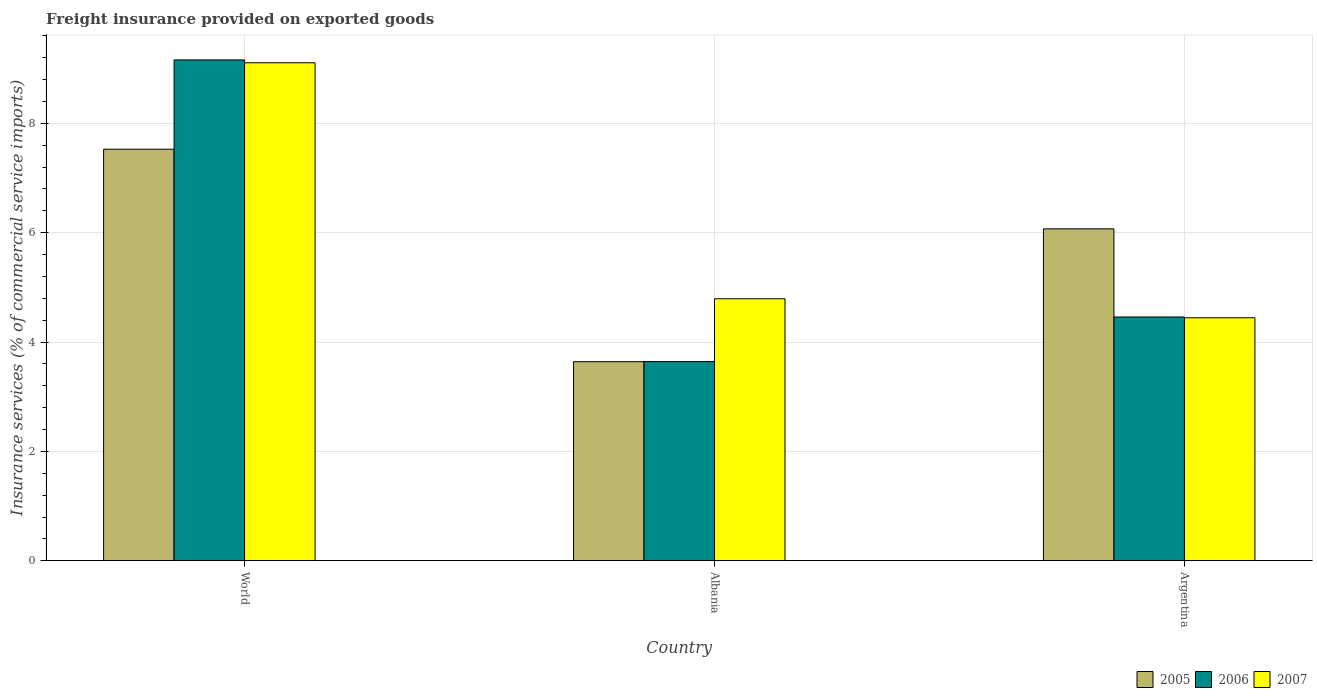How many groups of bars are there?
Offer a terse response. 3. Are the number of bars per tick equal to the number of legend labels?
Provide a succinct answer. Yes. How many bars are there on the 2nd tick from the right?
Give a very brief answer. 3. What is the label of the 2nd group of bars from the left?
Your response must be concise. Albania. What is the freight insurance provided on exported goods in 2006 in Argentina?
Ensure brevity in your answer.  4.46. Across all countries, what is the maximum freight insurance provided on exported goods in 2007?
Give a very brief answer. 9.11. Across all countries, what is the minimum freight insurance provided on exported goods in 2007?
Offer a terse response. 4.44. In which country was the freight insurance provided on exported goods in 2006 maximum?
Ensure brevity in your answer.  World. What is the total freight insurance provided on exported goods in 2006 in the graph?
Your response must be concise. 17.26. What is the difference between the freight insurance provided on exported goods in 2005 in Albania and that in Argentina?
Ensure brevity in your answer.  -2.43. What is the difference between the freight insurance provided on exported goods in 2005 in World and the freight insurance provided on exported goods in 2006 in Albania?
Offer a terse response. 3.88. What is the average freight insurance provided on exported goods in 2005 per country?
Give a very brief answer. 5.75. What is the difference between the freight insurance provided on exported goods of/in 2006 and freight insurance provided on exported goods of/in 2007 in Albania?
Your response must be concise. -1.15. In how many countries, is the freight insurance provided on exported goods in 2007 greater than 2.8 %?
Keep it short and to the point. 3. What is the ratio of the freight insurance provided on exported goods in 2006 in Albania to that in World?
Make the answer very short. 0.4. What is the difference between the highest and the second highest freight insurance provided on exported goods in 2006?
Ensure brevity in your answer.  5.52. What is the difference between the highest and the lowest freight insurance provided on exported goods in 2007?
Provide a succinct answer. 4.66. In how many countries, is the freight insurance provided on exported goods in 2005 greater than the average freight insurance provided on exported goods in 2005 taken over all countries?
Make the answer very short. 2. What does the 3rd bar from the left in Albania represents?
Keep it short and to the point. 2007. What does the 1st bar from the right in Argentina represents?
Offer a very short reply. 2007. Is it the case that in every country, the sum of the freight insurance provided on exported goods in 2006 and freight insurance provided on exported goods in 2005 is greater than the freight insurance provided on exported goods in 2007?
Keep it short and to the point. Yes. How many bars are there?
Keep it short and to the point. 9. Are all the bars in the graph horizontal?
Provide a succinct answer. No. What is the difference between two consecutive major ticks on the Y-axis?
Offer a very short reply. 2. Are the values on the major ticks of Y-axis written in scientific E-notation?
Provide a short and direct response. No. Where does the legend appear in the graph?
Keep it short and to the point. Bottom right. How many legend labels are there?
Your answer should be compact. 3. How are the legend labels stacked?
Your response must be concise. Horizontal. What is the title of the graph?
Keep it short and to the point. Freight insurance provided on exported goods. What is the label or title of the Y-axis?
Give a very brief answer. Insurance services (% of commercial service imports). What is the Insurance services (% of commercial service imports) in 2005 in World?
Offer a terse response. 7.53. What is the Insurance services (% of commercial service imports) of 2006 in World?
Your response must be concise. 9.16. What is the Insurance services (% of commercial service imports) of 2007 in World?
Provide a short and direct response. 9.11. What is the Insurance services (% of commercial service imports) of 2005 in Albania?
Give a very brief answer. 3.64. What is the Insurance services (% of commercial service imports) in 2006 in Albania?
Offer a very short reply. 3.64. What is the Insurance services (% of commercial service imports) in 2007 in Albania?
Provide a short and direct response. 4.79. What is the Insurance services (% of commercial service imports) in 2005 in Argentina?
Provide a short and direct response. 6.07. What is the Insurance services (% of commercial service imports) in 2006 in Argentina?
Offer a very short reply. 4.46. What is the Insurance services (% of commercial service imports) in 2007 in Argentina?
Offer a terse response. 4.44. Across all countries, what is the maximum Insurance services (% of commercial service imports) in 2005?
Provide a short and direct response. 7.53. Across all countries, what is the maximum Insurance services (% of commercial service imports) of 2006?
Offer a terse response. 9.16. Across all countries, what is the maximum Insurance services (% of commercial service imports) in 2007?
Offer a terse response. 9.11. Across all countries, what is the minimum Insurance services (% of commercial service imports) of 2005?
Keep it short and to the point. 3.64. Across all countries, what is the minimum Insurance services (% of commercial service imports) of 2006?
Ensure brevity in your answer.  3.64. Across all countries, what is the minimum Insurance services (% of commercial service imports) in 2007?
Give a very brief answer. 4.44. What is the total Insurance services (% of commercial service imports) in 2005 in the graph?
Provide a succinct answer. 17.23. What is the total Insurance services (% of commercial service imports) of 2006 in the graph?
Your answer should be very brief. 17.26. What is the total Insurance services (% of commercial service imports) of 2007 in the graph?
Provide a short and direct response. 18.34. What is the difference between the Insurance services (% of commercial service imports) of 2005 in World and that in Albania?
Your response must be concise. 3.89. What is the difference between the Insurance services (% of commercial service imports) in 2006 in World and that in Albania?
Your response must be concise. 5.52. What is the difference between the Insurance services (% of commercial service imports) of 2007 in World and that in Albania?
Your answer should be very brief. 4.31. What is the difference between the Insurance services (% of commercial service imports) in 2005 in World and that in Argentina?
Give a very brief answer. 1.46. What is the difference between the Insurance services (% of commercial service imports) of 2006 in World and that in Argentina?
Make the answer very short. 4.7. What is the difference between the Insurance services (% of commercial service imports) in 2007 in World and that in Argentina?
Ensure brevity in your answer.  4.66. What is the difference between the Insurance services (% of commercial service imports) of 2005 in Albania and that in Argentina?
Your response must be concise. -2.43. What is the difference between the Insurance services (% of commercial service imports) in 2006 in Albania and that in Argentina?
Ensure brevity in your answer.  -0.82. What is the difference between the Insurance services (% of commercial service imports) in 2007 in Albania and that in Argentina?
Your answer should be compact. 0.35. What is the difference between the Insurance services (% of commercial service imports) in 2005 in World and the Insurance services (% of commercial service imports) in 2006 in Albania?
Your response must be concise. 3.88. What is the difference between the Insurance services (% of commercial service imports) of 2005 in World and the Insurance services (% of commercial service imports) of 2007 in Albania?
Your response must be concise. 2.73. What is the difference between the Insurance services (% of commercial service imports) of 2006 in World and the Insurance services (% of commercial service imports) of 2007 in Albania?
Ensure brevity in your answer.  4.37. What is the difference between the Insurance services (% of commercial service imports) of 2005 in World and the Insurance services (% of commercial service imports) of 2006 in Argentina?
Offer a terse response. 3.07. What is the difference between the Insurance services (% of commercial service imports) of 2005 in World and the Insurance services (% of commercial service imports) of 2007 in Argentina?
Give a very brief answer. 3.08. What is the difference between the Insurance services (% of commercial service imports) of 2006 in World and the Insurance services (% of commercial service imports) of 2007 in Argentina?
Your response must be concise. 4.71. What is the difference between the Insurance services (% of commercial service imports) in 2005 in Albania and the Insurance services (% of commercial service imports) in 2006 in Argentina?
Your answer should be compact. -0.82. What is the difference between the Insurance services (% of commercial service imports) in 2005 in Albania and the Insurance services (% of commercial service imports) in 2007 in Argentina?
Provide a succinct answer. -0.8. What is the difference between the Insurance services (% of commercial service imports) of 2006 in Albania and the Insurance services (% of commercial service imports) of 2007 in Argentina?
Offer a terse response. -0.8. What is the average Insurance services (% of commercial service imports) of 2005 per country?
Keep it short and to the point. 5.75. What is the average Insurance services (% of commercial service imports) in 2006 per country?
Your answer should be very brief. 5.75. What is the average Insurance services (% of commercial service imports) of 2007 per country?
Your response must be concise. 6.11. What is the difference between the Insurance services (% of commercial service imports) of 2005 and Insurance services (% of commercial service imports) of 2006 in World?
Ensure brevity in your answer.  -1.63. What is the difference between the Insurance services (% of commercial service imports) in 2005 and Insurance services (% of commercial service imports) in 2007 in World?
Offer a terse response. -1.58. What is the difference between the Insurance services (% of commercial service imports) in 2006 and Insurance services (% of commercial service imports) in 2007 in World?
Make the answer very short. 0.05. What is the difference between the Insurance services (% of commercial service imports) of 2005 and Insurance services (% of commercial service imports) of 2006 in Albania?
Provide a succinct answer. -0. What is the difference between the Insurance services (% of commercial service imports) in 2005 and Insurance services (% of commercial service imports) in 2007 in Albania?
Provide a succinct answer. -1.15. What is the difference between the Insurance services (% of commercial service imports) of 2006 and Insurance services (% of commercial service imports) of 2007 in Albania?
Ensure brevity in your answer.  -1.15. What is the difference between the Insurance services (% of commercial service imports) in 2005 and Insurance services (% of commercial service imports) in 2006 in Argentina?
Keep it short and to the point. 1.61. What is the difference between the Insurance services (% of commercial service imports) in 2005 and Insurance services (% of commercial service imports) in 2007 in Argentina?
Keep it short and to the point. 1.63. What is the difference between the Insurance services (% of commercial service imports) in 2006 and Insurance services (% of commercial service imports) in 2007 in Argentina?
Ensure brevity in your answer.  0.01. What is the ratio of the Insurance services (% of commercial service imports) of 2005 in World to that in Albania?
Ensure brevity in your answer.  2.07. What is the ratio of the Insurance services (% of commercial service imports) of 2006 in World to that in Albania?
Your response must be concise. 2.51. What is the ratio of the Insurance services (% of commercial service imports) in 2007 in World to that in Albania?
Provide a short and direct response. 1.9. What is the ratio of the Insurance services (% of commercial service imports) in 2005 in World to that in Argentina?
Your response must be concise. 1.24. What is the ratio of the Insurance services (% of commercial service imports) in 2006 in World to that in Argentina?
Keep it short and to the point. 2.05. What is the ratio of the Insurance services (% of commercial service imports) of 2007 in World to that in Argentina?
Offer a terse response. 2.05. What is the ratio of the Insurance services (% of commercial service imports) in 2005 in Albania to that in Argentina?
Give a very brief answer. 0.6. What is the ratio of the Insurance services (% of commercial service imports) in 2006 in Albania to that in Argentina?
Provide a short and direct response. 0.82. What is the ratio of the Insurance services (% of commercial service imports) of 2007 in Albania to that in Argentina?
Your answer should be compact. 1.08. What is the difference between the highest and the second highest Insurance services (% of commercial service imports) in 2005?
Make the answer very short. 1.46. What is the difference between the highest and the second highest Insurance services (% of commercial service imports) of 2006?
Keep it short and to the point. 4.7. What is the difference between the highest and the second highest Insurance services (% of commercial service imports) of 2007?
Keep it short and to the point. 4.31. What is the difference between the highest and the lowest Insurance services (% of commercial service imports) in 2005?
Offer a terse response. 3.89. What is the difference between the highest and the lowest Insurance services (% of commercial service imports) of 2006?
Offer a very short reply. 5.52. What is the difference between the highest and the lowest Insurance services (% of commercial service imports) of 2007?
Offer a terse response. 4.66. 